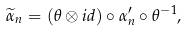<formula> <loc_0><loc_0><loc_500><loc_500>\widetilde { \alpha } _ { n } = ( \theta \otimes i d ) \circ \alpha _ { n } ^ { \prime } \circ \theta ^ { - 1 } ,</formula> 